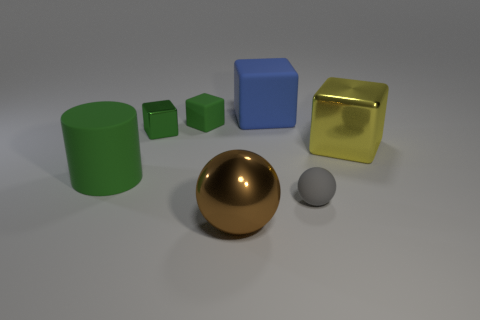Subtract all large yellow cubes. How many cubes are left? 3 Subtract all blue cubes. How many cubes are left? 3 Subtract all brown balls. How many green blocks are left? 2 Subtract 1 cubes. How many cubes are left? 3 Add 3 big spheres. How many objects exist? 10 Subtract all blocks. How many objects are left? 3 Add 6 large brown spheres. How many large brown spheres exist? 7 Subtract 0 red cylinders. How many objects are left? 7 Subtract all cyan blocks. Subtract all cyan spheres. How many blocks are left? 4 Subtract all purple rubber spheres. Subtract all big green cylinders. How many objects are left? 6 